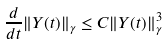<formula> <loc_0><loc_0><loc_500><loc_500>\frac { d } { d t } \| Y ( t ) \| _ { \gamma } \leq C \| Y ( t ) \| ^ { 3 } _ { \gamma }</formula> 